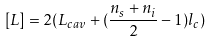Convert formula to latex. <formula><loc_0><loc_0><loc_500><loc_500>[ L ] = 2 ( L _ { c a v } + ( \frac { n _ { s } + n _ { i } } { 2 } - 1 ) l _ { c } )</formula> 